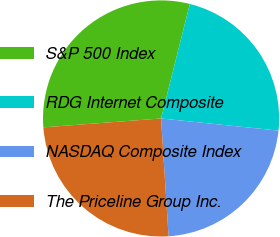Convert chart. <chart><loc_0><loc_0><loc_500><loc_500><pie_chart><fcel>S&P 500 Index<fcel>RDG Internet Composite<fcel>NASDAQ Composite Index<fcel>The Priceline Group Inc.<nl><fcel>30.12%<fcel>22.73%<fcel>22.35%<fcel>24.81%<nl></chart> 